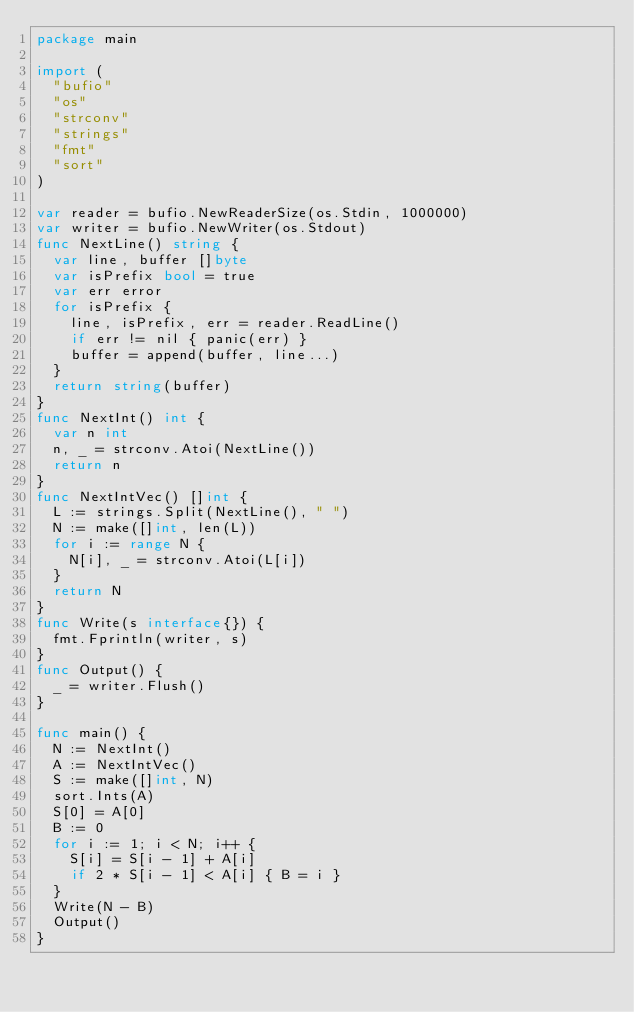Convert code to text. <code><loc_0><loc_0><loc_500><loc_500><_Go_>package main
 
import (
  "bufio"
  "os"
  "strconv"
  "strings"
  "fmt"
  "sort"
)
 
var reader = bufio.NewReaderSize(os.Stdin, 1000000)
var writer = bufio.NewWriter(os.Stdout)
func NextLine() string {
  var line, buffer []byte
  var isPrefix bool = true
  var err error
  for isPrefix {
    line, isPrefix, err = reader.ReadLine()
    if err != nil { panic(err) }
    buffer = append(buffer, line...)
  }
  return string(buffer)
}
func NextInt() int {
  var n int
  n, _ = strconv.Atoi(NextLine())
  return n
}
func NextIntVec() []int {
  L := strings.Split(NextLine(), " ")
  N := make([]int, len(L))
  for i := range N {
    N[i], _ = strconv.Atoi(L[i])
  }
  return N
}
func Write(s interface{}) {
  fmt.Fprintln(writer, s)
}
func Output() {
  _ = writer.Flush()
}

func main() {
  N := NextInt()
  A := NextIntVec()
  S := make([]int, N)
  sort.Ints(A)
  S[0] = A[0]
  B := 0
  for i := 1; i < N; i++ {
    S[i] = S[i - 1] + A[i]
    if 2 * S[i - 1] < A[i] { B = i }
  }
  Write(N - B)
  Output()
}</code> 